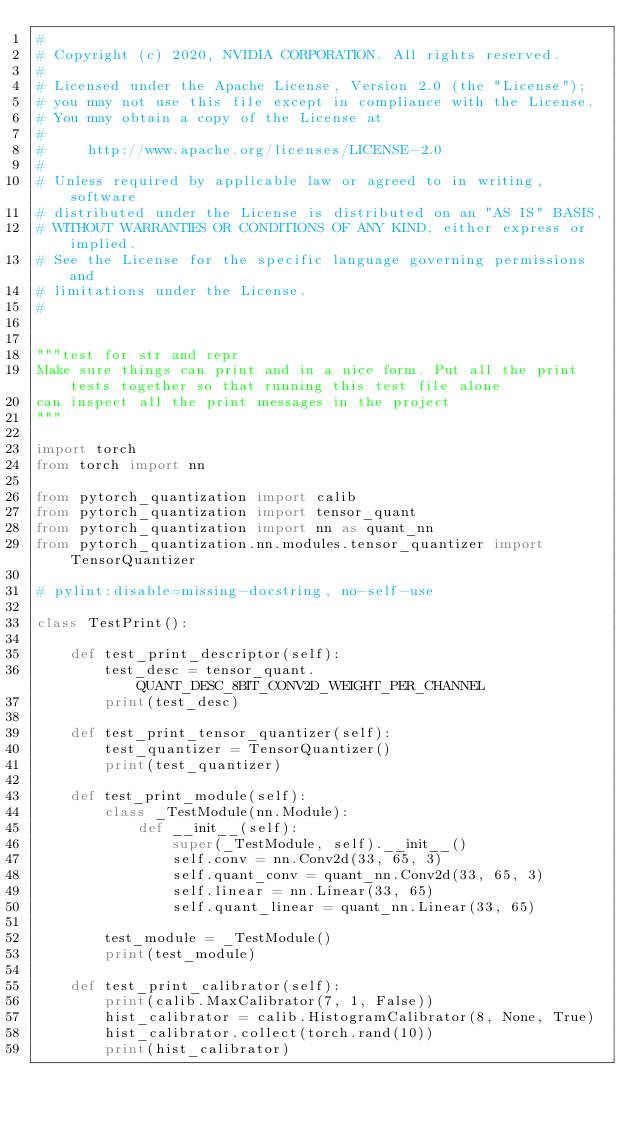<code> <loc_0><loc_0><loc_500><loc_500><_Python_>#
# Copyright (c) 2020, NVIDIA CORPORATION. All rights reserved.
#
# Licensed under the Apache License, Version 2.0 (the "License");
# you may not use this file except in compliance with the License.
# You may obtain a copy of the License at
#
#     http://www.apache.org/licenses/LICENSE-2.0
#
# Unless required by applicable law or agreed to in writing, software
# distributed under the License is distributed on an "AS IS" BASIS,
# WITHOUT WARRANTIES OR CONDITIONS OF ANY KIND, either express or implied.
# See the License for the specific language governing permissions and
# limitations under the License.
#


"""test for str and repr
Make sure things can print and in a nice form. Put all the print tests together so that running this test file alone
can inspect all the print messages in the project
"""

import torch
from torch import nn

from pytorch_quantization import calib
from pytorch_quantization import tensor_quant
from pytorch_quantization import nn as quant_nn
from pytorch_quantization.nn.modules.tensor_quantizer import TensorQuantizer

# pylint:disable=missing-docstring, no-self-use

class TestPrint():

    def test_print_descriptor(self):
        test_desc = tensor_quant.QUANT_DESC_8BIT_CONV2D_WEIGHT_PER_CHANNEL
        print(test_desc)

    def test_print_tensor_quantizer(self):
        test_quantizer = TensorQuantizer()
        print(test_quantizer)

    def test_print_module(self):
        class _TestModule(nn.Module):
            def __init__(self):
                super(_TestModule, self).__init__()
                self.conv = nn.Conv2d(33, 65, 3)
                self.quant_conv = quant_nn.Conv2d(33, 65, 3)
                self.linear = nn.Linear(33, 65)
                self.quant_linear = quant_nn.Linear(33, 65)

        test_module = _TestModule()
        print(test_module)

    def test_print_calibrator(self):
        print(calib.MaxCalibrator(7, 1, False))
        hist_calibrator = calib.HistogramCalibrator(8, None, True)
        hist_calibrator.collect(torch.rand(10))
        print(hist_calibrator)
</code> 